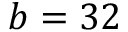Convert formula to latex. <formula><loc_0><loc_0><loc_500><loc_500>b = 3 2</formula> 